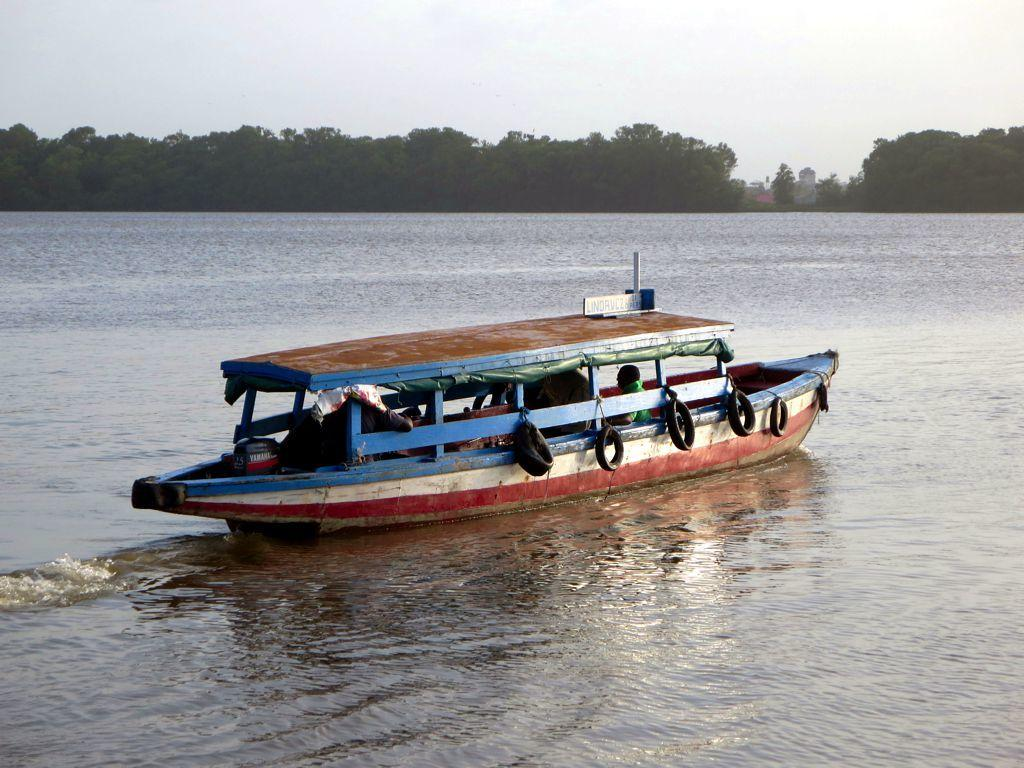What is the main subject of the image? The main subject of the image is a boat. Where is the boat located? The boat is on the water. Are there any people in the boat? Yes, there are people inside the boat. What is the color of the boat? The boat is colorful. What can be seen in the background of the image? There are many trees in the background. What is the color of the sky in the image? The sky is white. Can you tell me how many frames are in the image? There are no frames present in the image; it is a photograph or digital image without a frame. What type of animal can be seen climbing a tree in the image? There is no animal climbing a tree in the image; only trees are visible in the background. 